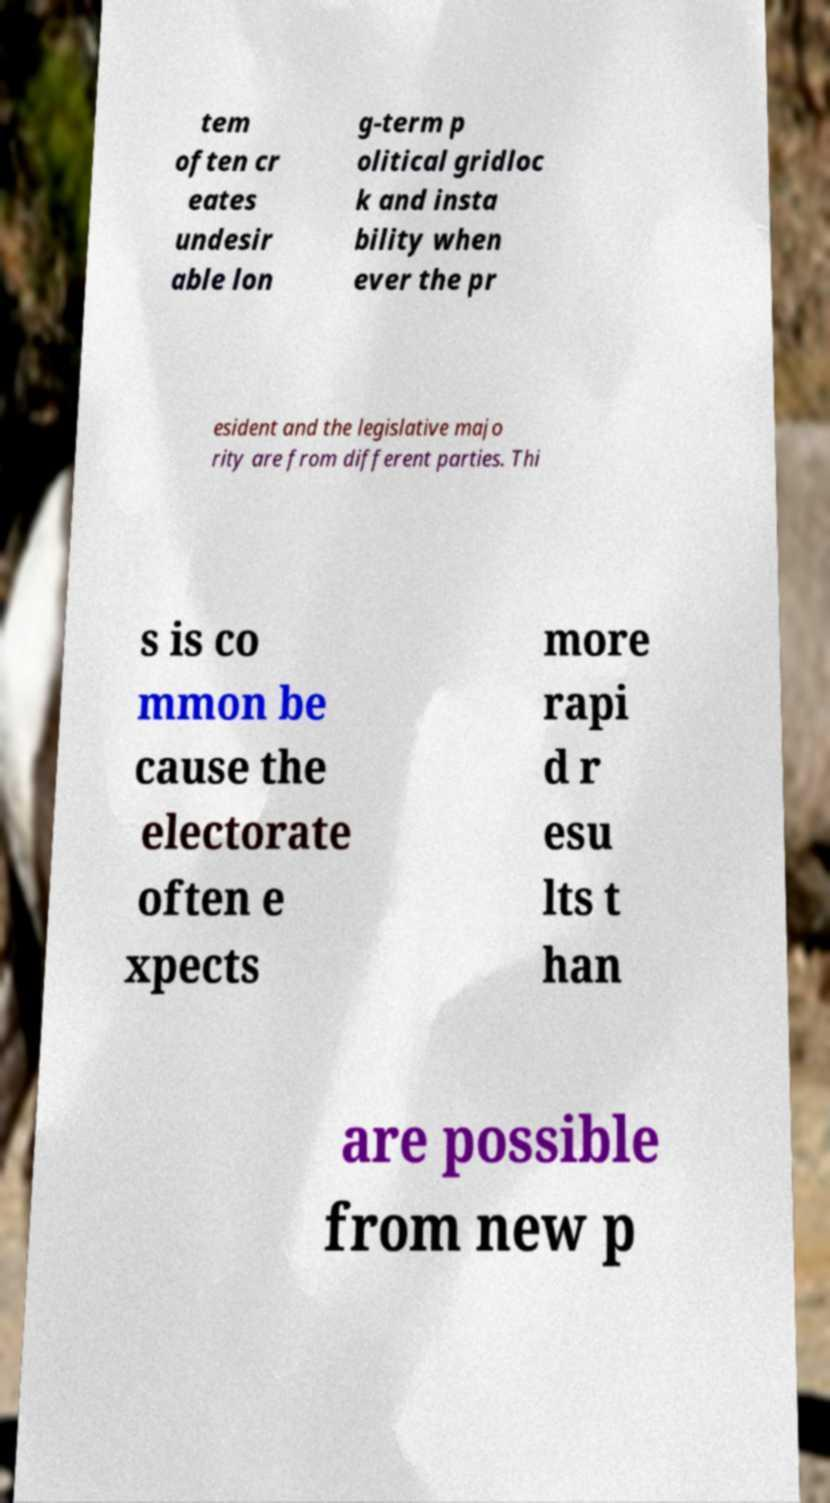For documentation purposes, I need the text within this image transcribed. Could you provide that? tem often cr eates undesir able lon g-term p olitical gridloc k and insta bility when ever the pr esident and the legislative majo rity are from different parties. Thi s is co mmon be cause the electorate often e xpects more rapi d r esu lts t han are possible from new p 